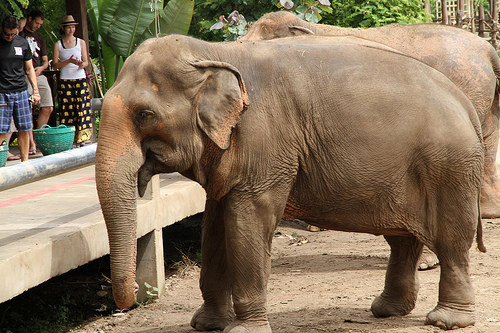What kind of animal is behind the floor? The animal behind the floor is an elephant. 